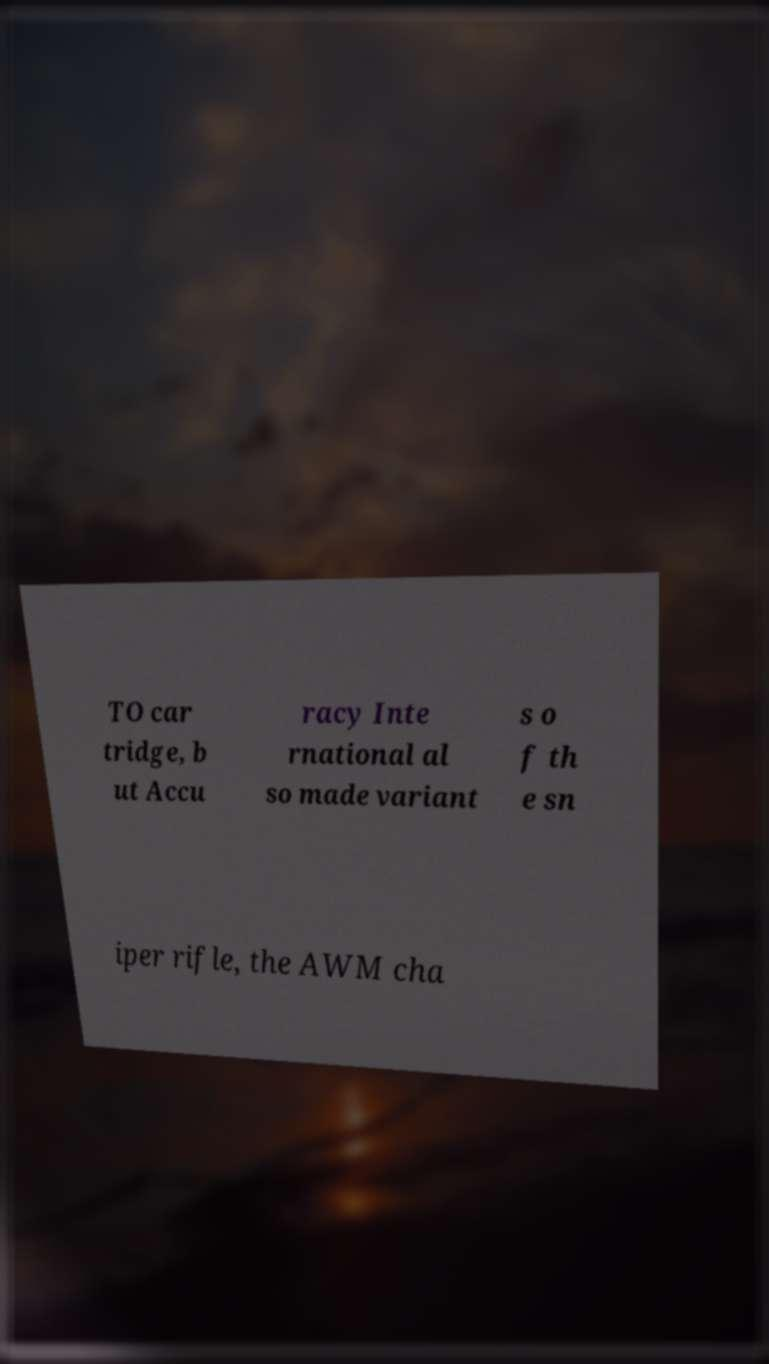Please identify and transcribe the text found in this image. TO car tridge, b ut Accu racy Inte rnational al so made variant s o f th e sn iper rifle, the AWM cha 